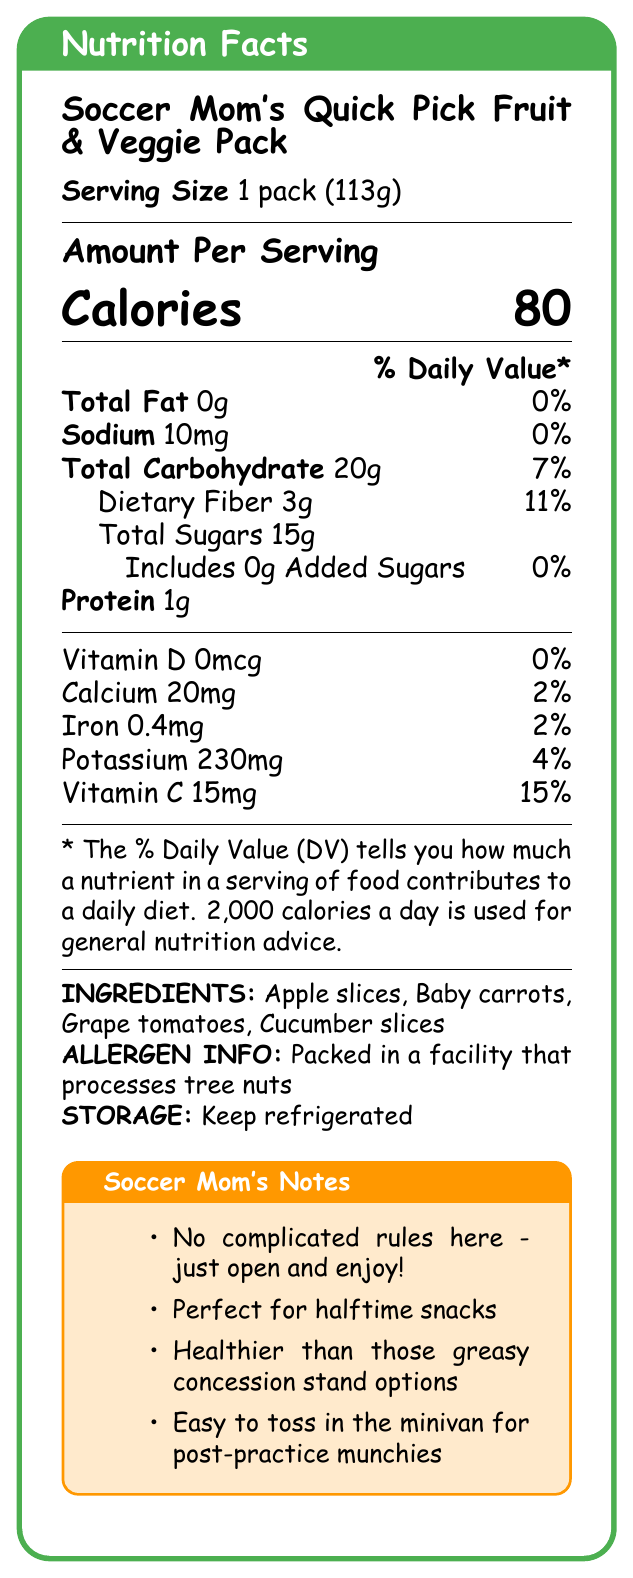how many calories are in the Soccer Mom's Quick Pick Fruit & Veggie Pack? The document lists the calories as 80 under the "Amount Per Serving" section.
Answer: 80 what is the serving size of the pack? The serving size is explicitly mentioned as "1 pack (113g)" near the top of the document.
Answer: 1 pack (113g) what percentage of the daily value for dietary fiber does this snack pack provide? The daily value for dietary fiber is noted as 11% in the section detailing Total Carbohydrate.
Answer: 11% are there any added sugars in the Soccer Mom's Quick Pick Fruit & Veggie Pack? The document clearly states that there are 0g of added sugars, which is 0% of the daily value.
Answer: No what are the main ingredients in this snack pack? The ingredients listed in the document are Apple slices, Baby carrots, Grape tomatoes, and Cucumber slices.
Answer: Apple slices, Baby carrots, Grape tomatoes, Cucumber slices how much protein does one pack contain? The document states that the pack contains 1g of protein.
Answer: 1g how is this snack pack supposed to be stored? Under the Storage section, it is mentioned that the pack should be kept refrigerated.
Answer: Keep refrigerated what is the amount of calcium present in the snack pack? The document lists the calcium content as 20mg with a 2% daily value.
Answer: 20mg what is the iron content in one serving of this snack pack? A. 0.4mg B. 20mg C. 230mg D. 15mg The iron content is listed as 0.4mg with a daily value of 2%.
Answer: A. 0.4mg which nutrient has the highest percentage of daily value in this snack pack? A. Vitamin D B. Calcium C. Iron D. Vitamin C Vitamin C has the highest daily value percentage at 15%, as indicated in the document.
Answer: D. Vitamin C is this snack pack healthier than typical greasy concession stand options? According to the Soccer Mom’s Notes, this snack pack is specifically mentioned as being healthier than greasy concession stand options.
Answer: Yes summarize the main idea of the document. The document details the serving size, nutritional information, ingredients, and allergen info, while also including mom-friendly notes that emphasize easy usage and health benefits.
Answer: The document provides comprehensive nutrition facts and ingredient details for the pre-packaged "Soccer Mom's Quick Pick Fruit & Veggie Pack," highlighting its health benefits and simplicity for busy moms. can I determine which facility packed this snack pack? The document only mentions that the snack is packed in a facility that processes tree nuts but does not specify which facility it is.
Answer: Not enough information does this pack contain any vitamin D? The document lists Vitamin D as 0mcg with a daily value of 0%.
Answer: No 